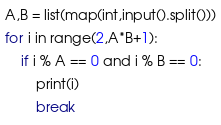<code> <loc_0><loc_0><loc_500><loc_500><_Python_>A,B = list(map(int,input().split()))
for i in range(2,A*B+1):
    if i % A == 0 and i % B == 0:
        print(i)
        break
</code> 